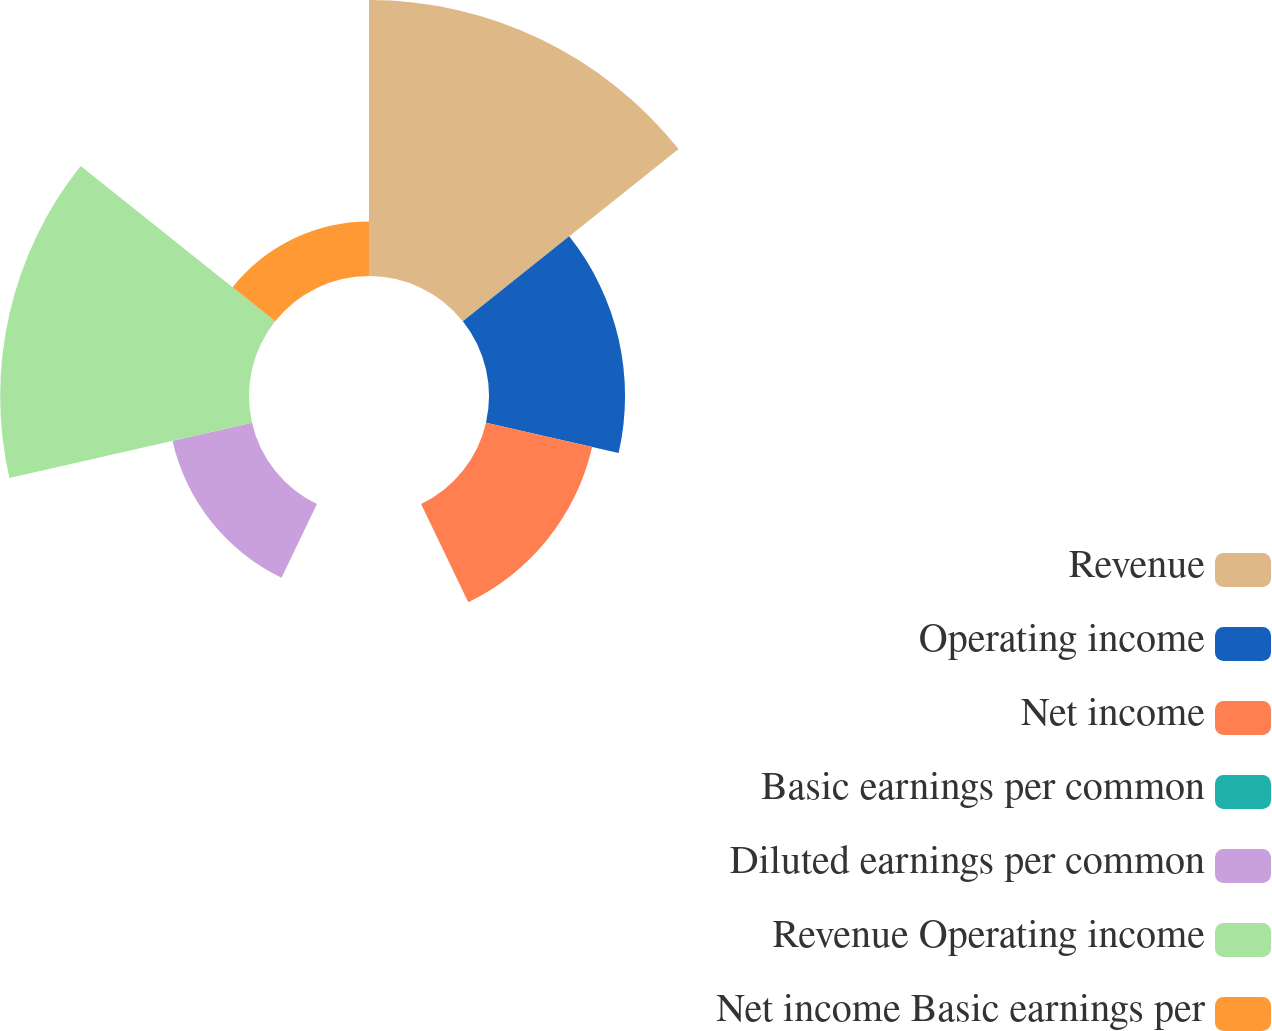Convert chart. <chart><loc_0><loc_0><loc_500><loc_500><pie_chart><fcel>Revenue<fcel>Operating income<fcel>Net income<fcel>Basic earnings per common<fcel>Diluted earnings per common<fcel>Revenue Operating income<fcel>Net income Basic earnings per<nl><fcel>30.47%<fcel>15.02%<fcel>12.02%<fcel>0.0%<fcel>9.01%<fcel>27.47%<fcel>6.01%<nl></chart> 